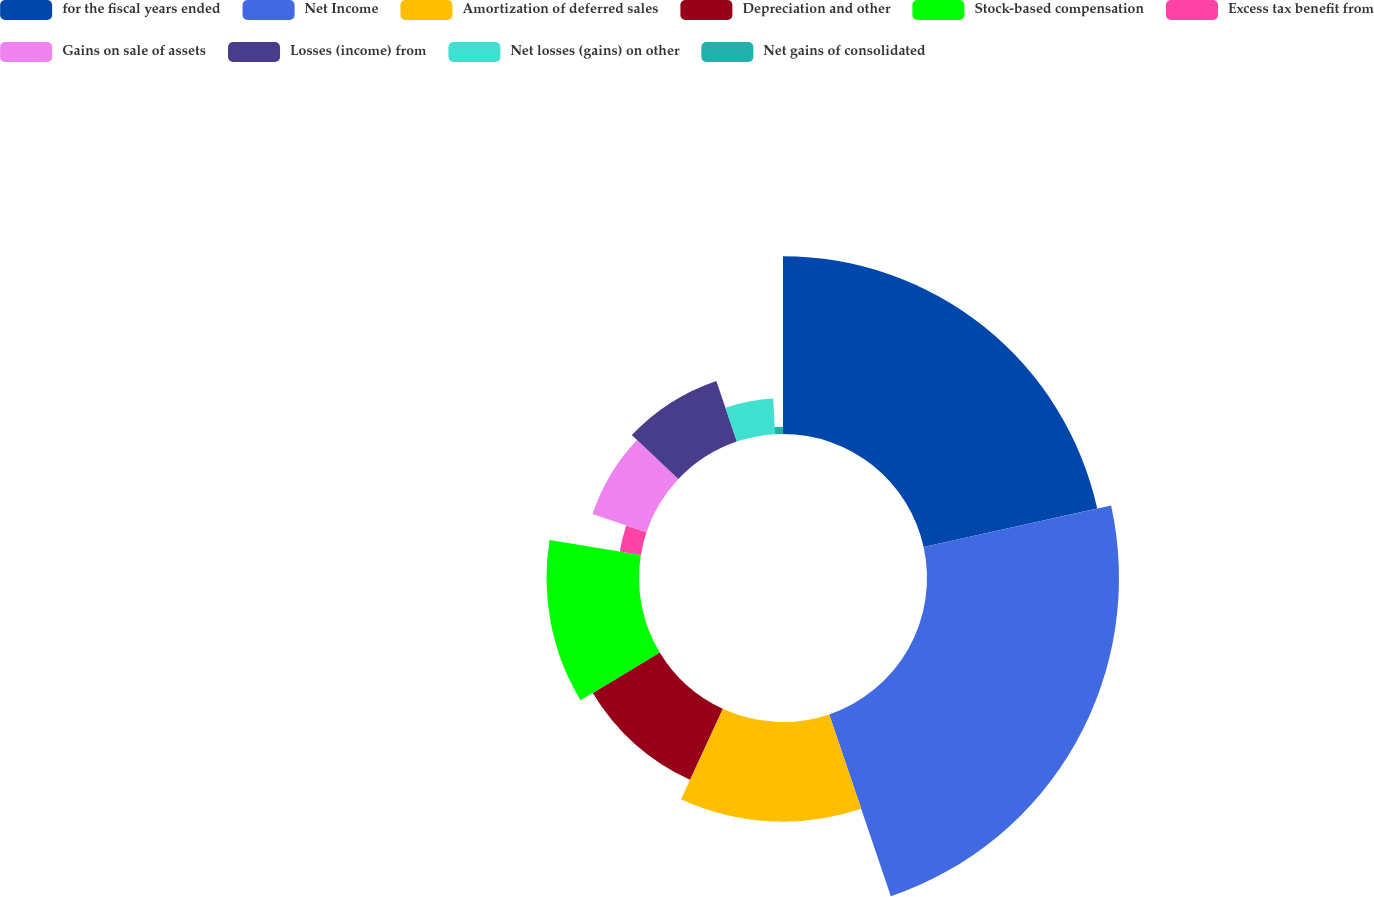<chart> <loc_0><loc_0><loc_500><loc_500><pie_chart><fcel>for the fiscal years ended<fcel>Net Income<fcel>Amortization of deferred sales<fcel>Depreciation and other<fcel>Stock-based compensation<fcel>Excess tax benefit from<fcel>Gains on sale of assets<fcel>Losses (income) from<fcel>Net losses (gains) on other<fcel>Net gains of consolidated<nl><fcel>21.54%<fcel>23.26%<fcel>12.07%<fcel>9.48%<fcel>11.21%<fcel>2.59%<fcel>6.9%<fcel>7.76%<fcel>4.32%<fcel>0.87%<nl></chart> 